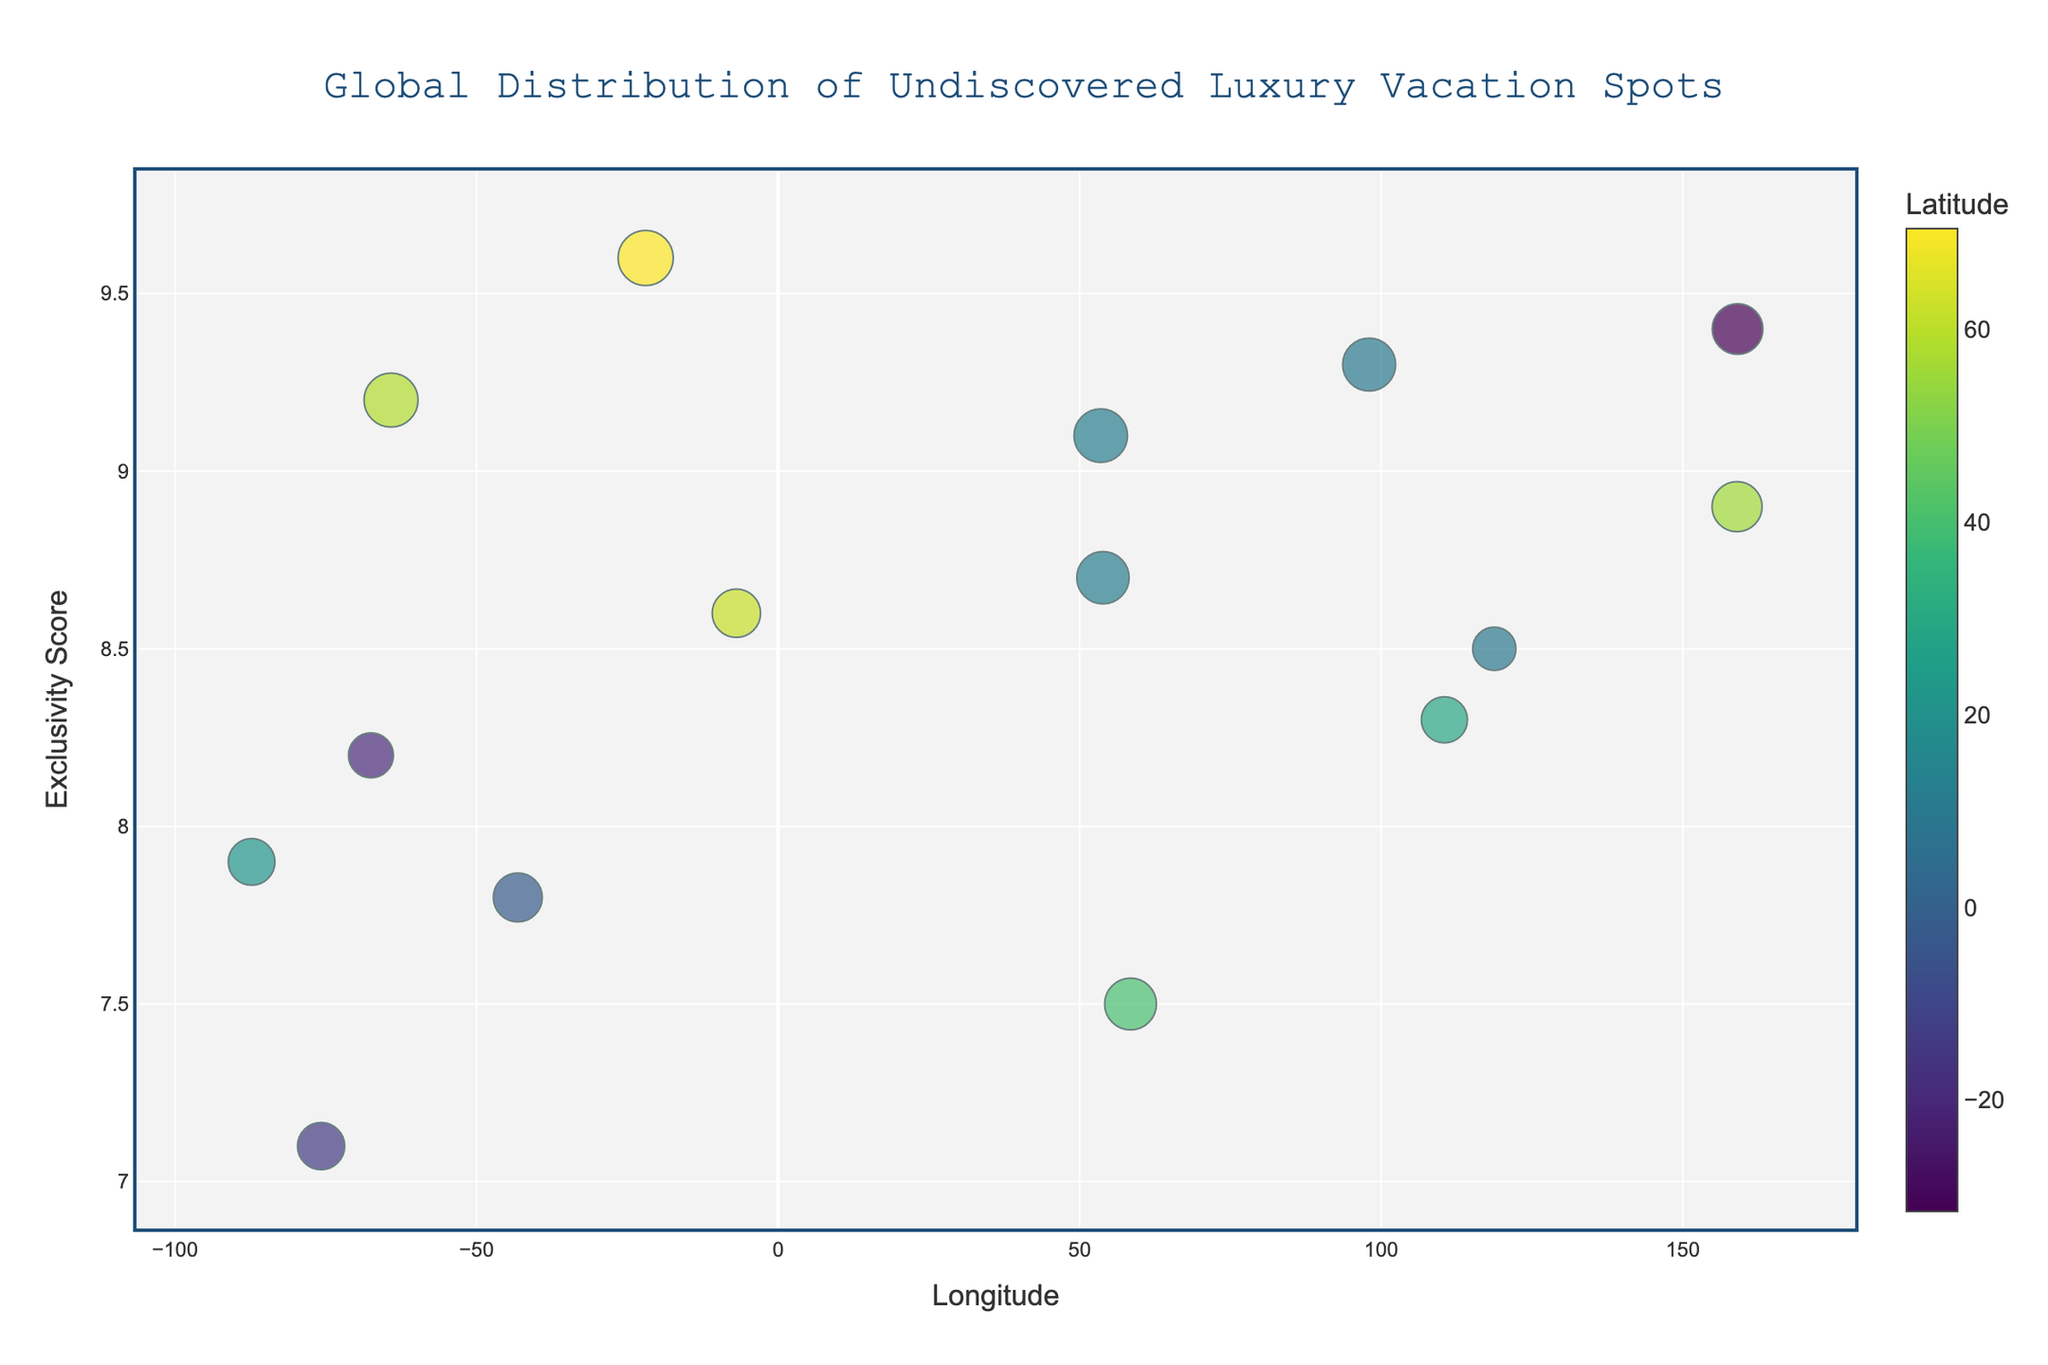How many luxury vacation spots are displayed in the figure? To determine the number of luxury vacation spots displayed in the figure, count the number of markers on the scatter plot. Each marker represents one location.
Answer: 15 What does the color of the marker represent? Refer to the color scale provided in the plot, which is labeled 'Latitude.' The colors of the markers correspond to the latitude of each location.
Answer: Latitude Which location has the highest Exclusivity Score? To find the location with the highest Exclusivity Score, look at the y-axis and identify the data point that reaches the maximum value on this axis.
Answer: Ittoqqortoormiit Which location has the highest Undiscovered Index size? Observe the size of the markers, as the marker size represents the Undiscovered Index. The largest marker corresponds to the location with the highest Undiscovered Index.
Answer: Ittoqqortoormiit Which two locations have the closest Longitude values? To determine the closest Longitude values, look at the x-axis and identify the two markers that are closest to each other.
Answer: Socotra Island and Socotra Archipelago What is the Exclusivity Score of the location at Longitude 159.0000? Identify the data point on the x-axis at Longitude 159.0000 and then read its corresponding value on the y-axis for Exclusivity Score.
Answer: 8.9 Which location at Latitude 70.4833 has the Exclusivity Score? Look at the color scale to find the latitude value and locate the corresponding marker. Then, check the y-axis value for its Exclusivity Score.
Answer: Ittoqqortoormiit with Exclusivity Score 9.6 Compare the Exclusivity Score of Socotra Island and Kamchatka Peninsula. Which one is higher? Identify the markers for Socotra Island and Kamchatka Peninsula on the plot. Then, compare their y-axis values to see which Exclusivity Score is higher.
Answer: Kamchatka Peninsula Which location has both high Exclusivity Score and Undiscovered Index? Identify the markers that are near the top of the y-axis (high Exclusivity Score) and have large marker sizes (high Undiscovered Index). For example, Ittoqqortoormiit has both high values.
Answer: Ittoqqortoormiit What is the relationship between Exclusivity Score and Longitude for the locations? Observe the overall trend in the scatter plot by looking at how the markers are distributed horizontally (Longitude) and vertically (Exclusivity Score).
Answer: There is no obvious linear relationship 